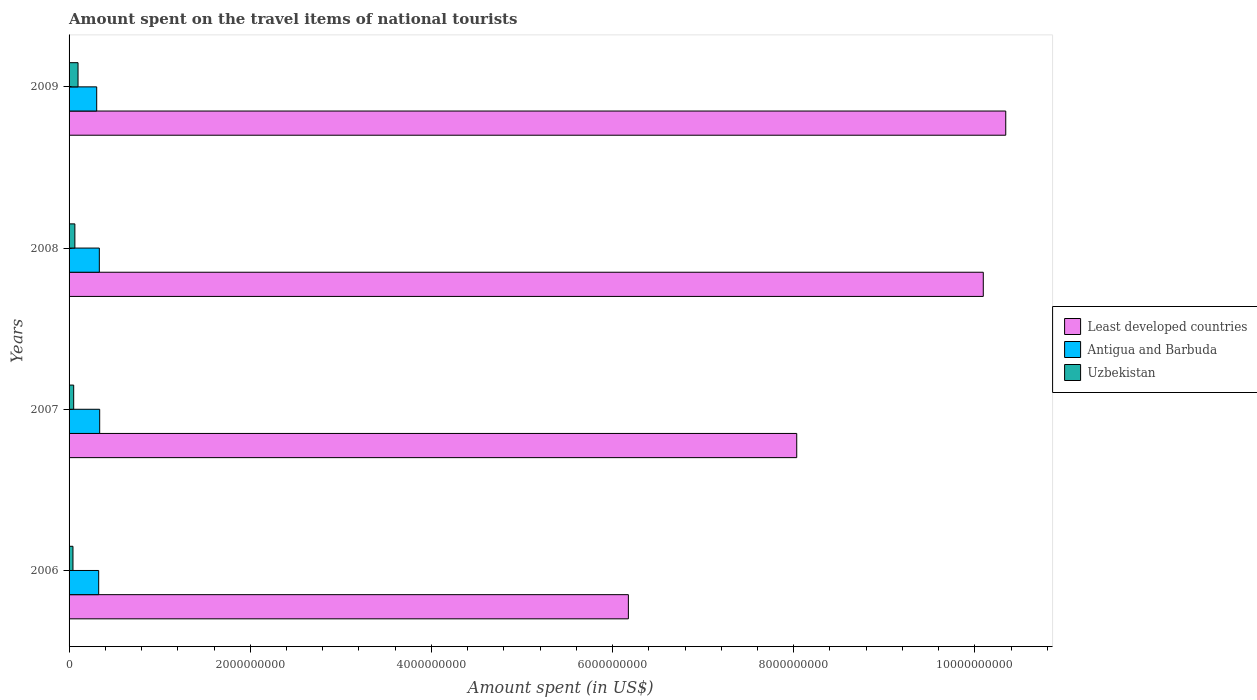How many groups of bars are there?
Ensure brevity in your answer.  4. Are the number of bars per tick equal to the number of legend labels?
Your response must be concise. Yes. Are the number of bars on each tick of the Y-axis equal?
Make the answer very short. Yes. What is the label of the 1st group of bars from the top?
Offer a very short reply. 2009. What is the amount spent on the travel items of national tourists in Least developed countries in 2008?
Provide a short and direct response. 1.01e+1. Across all years, what is the maximum amount spent on the travel items of national tourists in Uzbekistan?
Your answer should be very brief. 9.90e+07. Across all years, what is the minimum amount spent on the travel items of national tourists in Least developed countries?
Keep it short and to the point. 6.17e+09. What is the total amount spent on the travel items of national tourists in Uzbekistan in the graph?
Keep it short and to the point. 2.57e+08. What is the difference between the amount spent on the travel items of national tourists in Antigua and Barbuda in 2006 and that in 2007?
Keep it short and to the point. -1.10e+07. What is the difference between the amount spent on the travel items of national tourists in Antigua and Barbuda in 2006 and the amount spent on the travel items of national tourists in Least developed countries in 2007?
Offer a very short reply. -7.71e+09. What is the average amount spent on the travel items of national tourists in Least developed countries per year?
Give a very brief answer. 8.66e+09. In the year 2008, what is the difference between the amount spent on the travel items of national tourists in Least developed countries and amount spent on the travel items of national tourists in Antigua and Barbuda?
Provide a succinct answer. 9.76e+09. What is the ratio of the amount spent on the travel items of national tourists in Least developed countries in 2006 to that in 2009?
Ensure brevity in your answer.  0.6. What is the difference between the highest and the second highest amount spent on the travel items of national tourists in Least developed countries?
Provide a short and direct response. 2.48e+08. What is the difference between the highest and the lowest amount spent on the travel items of national tourists in Antigua and Barbuda?
Offer a very short reply. 3.30e+07. What does the 1st bar from the top in 2008 represents?
Keep it short and to the point. Uzbekistan. What does the 1st bar from the bottom in 2006 represents?
Your answer should be very brief. Least developed countries. Is it the case that in every year, the sum of the amount spent on the travel items of national tourists in Antigua and Barbuda and amount spent on the travel items of national tourists in Uzbekistan is greater than the amount spent on the travel items of national tourists in Least developed countries?
Make the answer very short. No. How many bars are there?
Your response must be concise. 12. Are the values on the major ticks of X-axis written in scientific E-notation?
Your answer should be compact. No. How many legend labels are there?
Your answer should be compact. 3. How are the legend labels stacked?
Your answer should be compact. Vertical. What is the title of the graph?
Make the answer very short. Amount spent on the travel items of national tourists. Does "Middle East & North Africa (all income levels)" appear as one of the legend labels in the graph?
Make the answer very short. No. What is the label or title of the X-axis?
Give a very brief answer. Amount spent (in US$). What is the label or title of the Y-axis?
Make the answer very short. Years. What is the Amount spent (in US$) of Least developed countries in 2006?
Make the answer very short. 6.17e+09. What is the Amount spent (in US$) of Antigua and Barbuda in 2006?
Give a very brief answer. 3.27e+08. What is the Amount spent (in US$) in Uzbekistan in 2006?
Provide a short and direct response. 4.30e+07. What is the Amount spent (in US$) in Least developed countries in 2007?
Your response must be concise. 8.03e+09. What is the Amount spent (in US$) in Antigua and Barbuda in 2007?
Offer a very short reply. 3.38e+08. What is the Amount spent (in US$) in Uzbekistan in 2007?
Give a very brief answer. 5.10e+07. What is the Amount spent (in US$) of Least developed countries in 2008?
Your answer should be compact. 1.01e+1. What is the Amount spent (in US$) of Antigua and Barbuda in 2008?
Ensure brevity in your answer.  3.34e+08. What is the Amount spent (in US$) of Uzbekistan in 2008?
Keep it short and to the point. 6.40e+07. What is the Amount spent (in US$) in Least developed countries in 2009?
Give a very brief answer. 1.03e+1. What is the Amount spent (in US$) of Antigua and Barbuda in 2009?
Provide a succinct answer. 3.05e+08. What is the Amount spent (in US$) in Uzbekistan in 2009?
Provide a short and direct response. 9.90e+07. Across all years, what is the maximum Amount spent (in US$) in Least developed countries?
Offer a very short reply. 1.03e+1. Across all years, what is the maximum Amount spent (in US$) of Antigua and Barbuda?
Your answer should be very brief. 3.38e+08. Across all years, what is the maximum Amount spent (in US$) of Uzbekistan?
Give a very brief answer. 9.90e+07. Across all years, what is the minimum Amount spent (in US$) of Least developed countries?
Your answer should be very brief. 6.17e+09. Across all years, what is the minimum Amount spent (in US$) in Antigua and Barbuda?
Offer a very short reply. 3.05e+08. Across all years, what is the minimum Amount spent (in US$) in Uzbekistan?
Your answer should be very brief. 4.30e+07. What is the total Amount spent (in US$) of Least developed countries in the graph?
Your response must be concise. 3.46e+1. What is the total Amount spent (in US$) in Antigua and Barbuda in the graph?
Your answer should be compact. 1.30e+09. What is the total Amount spent (in US$) in Uzbekistan in the graph?
Your answer should be compact. 2.57e+08. What is the difference between the Amount spent (in US$) of Least developed countries in 2006 and that in 2007?
Make the answer very short. -1.86e+09. What is the difference between the Amount spent (in US$) of Antigua and Barbuda in 2006 and that in 2007?
Provide a succinct answer. -1.10e+07. What is the difference between the Amount spent (in US$) in Uzbekistan in 2006 and that in 2007?
Provide a succinct answer. -8.00e+06. What is the difference between the Amount spent (in US$) of Least developed countries in 2006 and that in 2008?
Your answer should be compact. -3.92e+09. What is the difference between the Amount spent (in US$) in Antigua and Barbuda in 2006 and that in 2008?
Offer a very short reply. -7.00e+06. What is the difference between the Amount spent (in US$) in Uzbekistan in 2006 and that in 2008?
Ensure brevity in your answer.  -2.10e+07. What is the difference between the Amount spent (in US$) in Least developed countries in 2006 and that in 2009?
Offer a terse response. -4.17e+09. What is the difference between the Amount spent (in US$) in Antigua and Barbuda in 2006 and that in 2009?
Ensure brevity in your answer.  2.20e+07. What is the difference between the Amount spent (in US$) in Uzbekistan in 2006 and that in 2009?
Offer a very short reply. -5.60e+07. What is the difference between the Amount spent (in US$) in Least developed countries in 2007 and that in 2008?
Offer a terse response. -2.06e+09. What is the difference between the Amount spent (in US$) in Uzbekistan in 2007 and that in 2008?
Offer a terse response. -1.30e+07. What is the difference between the Amount spent (in US$) in Least developed countries in 2007 and that in 2009?
Your answer should be compact. -2.31e+09. What is the difference between the Amount spent (in US$) in Antigua and Barbuda in 2007 and that in 2009?
Your response must be concise. 3.30e+07. What is the difference between the Amount spent (in US$) in Uzbekistan in 2007 and that in 2009?
Offer a terse response. -4.80e+07. What is the difference between the Amount spent (in US$) of Least developed countries in 2008 and that in 2009?
Ensure brevity in your answer.  -2.48e+08. What is the difference between the Amount spent (in US$) of Antigua and Barbuda in 2008 and that in 2009?
Provide a short and direct response. 2.90e+07. What is the difference between the Amount spent (in US$) of Uzbekistan in 2008 and that in 2009?
Make the answer very short. -3.50e+07. What is the difference between the Amount spent (in US$) in Least developed countries in 2006 and the Amount spent (in US$) in Antigua and Barbuda in 2007?
Your answer should be very brief. 5.84e+09. What is the difference between the Amount spent (in US$) of Least developed countries in 2006 and the Amount spent (in US$) of Uzbekistan in 2007?
Offer a terse response. 6.12e+09. What is the difference between the Amount spent (in US$) of Antigua and Barbuda in 2006 and the Amount spent (in US$) of Uzbekistan in 2007?
Provide a succinct answer. 2.76e+08. What is the difference between the Amount spent (in US$) of Least developed countries in 2006 and the Amount spent (in US$) of Antigua and Barbuda in 2008?
Your response must be concise. 5.84e+09. What is the difference between the Amount spent (in US$) in Least developed countries in 2006 and the Amount spent (in US$) in Uzbekistan in 2008?
Make the answer very short. 6.11e+09. What is the difference between the Amount spent (in US$) in Antigua and Barbuda in 2006 and the Amount spent (in US$) in Uzbekistan in 2008?
Give a very brief answer. 2.63e+08. What is the difference between the Amount spent (in US$) of Least developed countries in 2006 and the Amount spent (in US$) of Antigua and Barbuda in 2009?
Offer a terse response. 5.87e+09. What is the difference between the Amount spent (in US$) in Least developed countries in 2006 and the Amount spent (in US$) in Uzbekistan in 2009?
Your response must be concise. 6.08e+09. What is the difference between the Amount spent (in US$) in Antigua and Barbuda in 2006 and the Amount spent (in US$) in Uzbekistan in 2009?
Make the answer very short. 2.28e+08. What is the difference between the Amount spent (in US$) in Least developed countries in 2007 and the Amount spent (in US$) in Antigua and Barbuda in 2008?
Provide a short and direct response. 7.70e+09. What is the difference between the Amount spent (in US$) in Least developed countries in 2007 and the Amount spent (in US$) in Uzbekistan in 2008?
Ensure brevity in your answer.  7.97e+09. What is the difference between the Amount spent (in US$) in Antigua and Barbuda in 2007 and the Amount spent (in US$) in Uzbekistan in 2008?
Offer a very short reply. 2.74e+08. What is the difference between the Amount spent (in US$) of Least developed countries in 2007 and the Amount spent (in US$) of Antigua and Barbuda in 2009?
Offer a terse response. 7.73e+09. What is the difference between the Amount spent (in US$) in Least developed countries in 2007 and the Amount spent (in US$) in Uzbekistan in 2009?
Provide a succinct answer. 7.93e+09. What is the difference between the Amount spent (in US$) of Antigua and Barbuda in 2007 and the Amount spent (in US$) of Uzbekistan in 2009?
Your answer should be very brief. 2.39e+08. What is the difference between the Amount spent (in US$) in Least developed countries in 2008 and the Amount spent (in US$) in Antigua and Barbuda in 2009?
Ensure brevity in your answer.  9.79e+09. What is the difference between the Amount spent (in US$) of Least developed countries in 2008 and the Amount spent (in US$) of Uzbekistan in 2009?
Make the answer very short. 9.99e+09. What is the difference between the Amount spent (in US$) of Antigua and Barbuda in 2008 and the Amount spent (in US$) of Uzbekistan in 2009?
Offer a very short reply. 2.35e+08. What is the average Amount spent (in US$) in Least developed countries per year?
Give a very brief answer. 8.66e+09. What is the average Amount spent (in US$) in Antigua and Barbuda per year?
Make the answer very short. 3.26e+08. What is the average Amount spent (in US$) of Uzbekistan per year?
Ensure brevity in your answer.  6.42e+07. In the year 2006, what is the difference between the Amount spent (in US$) of Least developed countries and Amount spent (in US$) of Antigua and Barbuda?
Offer a terse response. 5.85e+09. In the year 2006, what is the difference between the Amount spent (in US$) in Least developed countries and Amount spent (in US$) in Uzbekistan?
Give a very brief answer. 6.13e+09. In the year 2006, what is the difference between the Amount spent (in US$) in Antigua and Barbuda and Amount spent (in US$) in Uzbekistan?
Offer a very short reply. 2.84e+08. In the year 2007, what is the difference between the Amount spent (in US$) of Least developed countries and Amount spent (in US$) of Antigua and Barbuda?
Keep it short and to the point. 7.70e+09. In the year 2007, what is the difference between the Amount spent (in US$) of Least developed countries and Amount spent (in US$) of Uzbekistan?
Offer a terse response. 7.98e+09. In the year 2007, what is the difference between the Amount spent (in US$) in Antigua and Barbuda and Amount spent (in US$) in Uzbekistan?
Offer a terse response. 2.87e+08. In the year 2008, what is the difference between the Amount spent (in US$) in Least developed countries and Amount spent (in US$) in Antigua and Barbuda?
Your response must be concise. 9.76e+09. In the year 2008, what is the difference between the Amount spent (in US$) of Least developed countries and Amount spent (in US$) of Uzbekistan?
Offer a very short reply. 1.00e+1. In the year 2008, what is the difference between the Amount spent (in US$) in Antigua and Barbuda and Amount spent (in US$) in Uzbekistan?
Your answer should be compact. 2.70e+08. In the year 2009, what is the difference between the Amount spent (in US$) in Least developed countries and Amount spent (in US$) in Antigua and Barbuda?
Make the answer very short. 1.00e+1. In the year 2009, what is the difference between the Amount spent (in US$) of Least developed countries and Amount spent (in US$) of Uzbekistan?
Keep it short and to the point. 1.02e+1. In the year 2009, what is the difference between the Amount spent (in US$) of Antigua and Barbuda and Amount spent (in US$) of Uzbekistan?
Your answer should be compact. 2.06e+08. What is the ratio of the Amount spent (in US$) in Least developed countries in 2006 to that in 2007?
Ensure brevity in your answer.  0.77. What is the ratio of the Amount spent (in US$) of Antigua and Barbuda in 2006 to that in 2007?
Your response must be concise. 0.97. What is the ratio of the Amount spent (in US$) in Uzbekistan in 2006 to that in 2007?
Keep it short and to the point. 0.84. What is the ratio of the Amount spent (in US$) in Least developed countries in 2006 to that in 2008?
Provide a short and direct response. 0.61. What is the ratio of the Amount spent (in US$) in Antigua and Barbuda in 2006 to that in 2008?
Offer a very short reply. 0.98. What is the ratio of the Amount spent (in US$) in Uzbekistan in 2006 to that in 2008?
Your answer should be very brief. 0.67. What is the ratio of the Amount spent (in US$) of Least developed countries in 2006 to that in 2009?
Offer a very short reply. 0.6. What is the ratio of the Amount spent (in US$) of Antigua and Barbuda in 2006 to that in 2009?
Give a very brief answer. 1.07. What is the ratio of the Amount spent (in US$) of Uzbekistan in 2006 to that in 2009?
Your answer should be compact. 0.43. What is the ratio of the Amount spent (in US$) of Least developed countries in 2007 to that in 2008?
Offer a very short reply. 0.8. What is the ratio of the Amount spent (in US$) of Uzbekistan in 2007 to that in 2008?
Your response must be concise. 0.8. What is the ratio of the Amount spent (in US$) in Least developed countries in 2007 to that in 2009?
Provide a succinct answer. 0.78. What is the ratio of the Amount spent (in US$) of Antigua and Barbuda in 2007 to that in 2009?
Your response must be concise. 1.11. What is the ratio of the Amount spent (in US$) in Uzbekistan in 2007 to that in 2009?
Give a very brief answer. 0.52. What is the ratio of the Amount spent (in US$) in Least developed countries in 2008 to that in 2009?
Provide a short and direct response. 0.98. What is the ratio of the Amount spent (in US$) in Antigua and Barbuda in 2008 to that in 2009?
Provide a short and direct response. 1.1. What is the ratio of the Amount spent (in US$) of Uzbekistan in 2008 to that in 2009?
Provide a short and direct response. 0.65. What is the difference between the highest and the second highest Amount spent (in US$) in Least developed countries?
Offer a very short reply. 2.48e+08. What is the difference between the highest and the second highest Amount spent (in US$) in Uzbekistan?
Your answer should be compact. 3.50e+07. What is the difference between the highest and the lowest Amount spent (in US$) of Least developed countries?
Make the answer very short. 4.17e+09. What is the difference between the highest and the lowest Amount spent (in US$) in Antigua and Barbuda?
Offer a very short reply. 3.30e+07. What is the difference between the highest and the lowest Amount spent (in US$) in Uzbekistan?
Provide a short and direct response. 5.60e+07. 